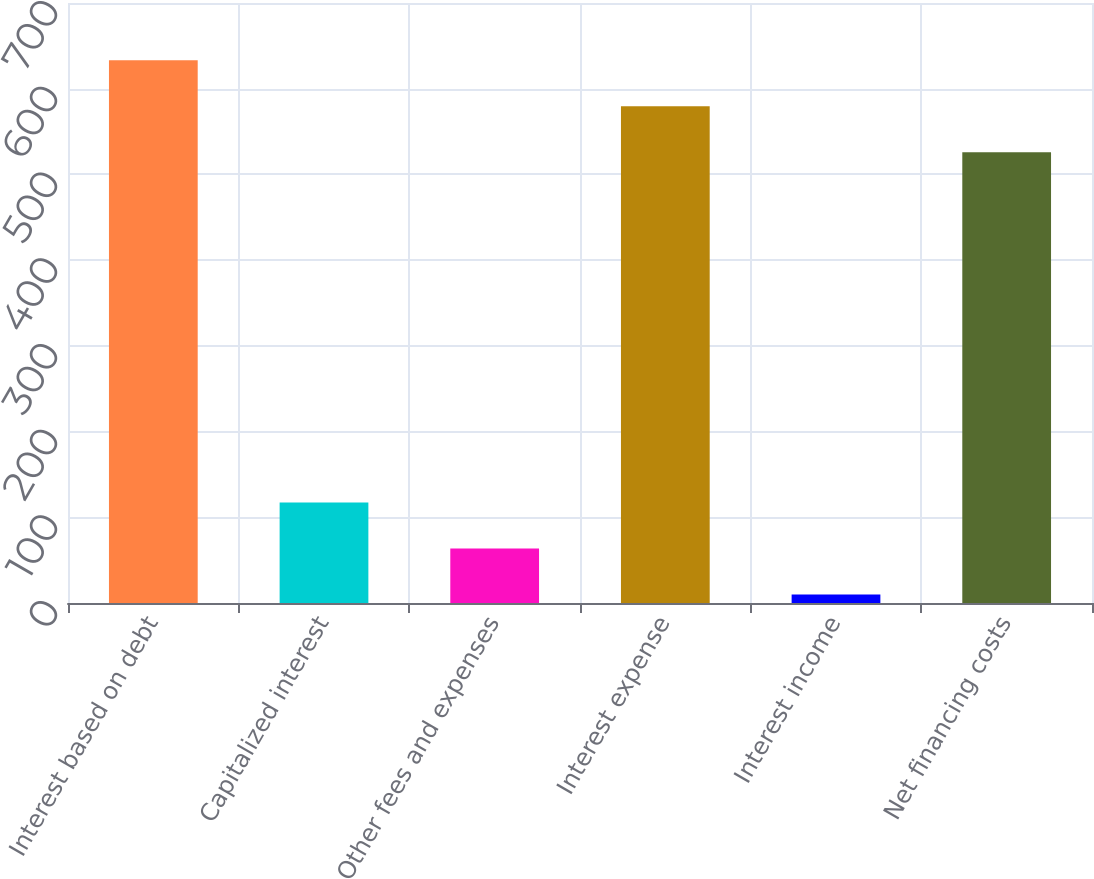Convert chart. <chart><loc_0><loc_0><loc_500><loc_500><bar_chart><fcel>Interest based on debt<fcel>Capitalized interest<fcel>Other fees and expenses<fcel>Interest expense<fcel>Interest income<fcel>Net financing costs<nl><fcel>633.2<fcel>117.2<fcel>63.6<fcel>579.6<fcel>10<fcel>526<nl></chart> 